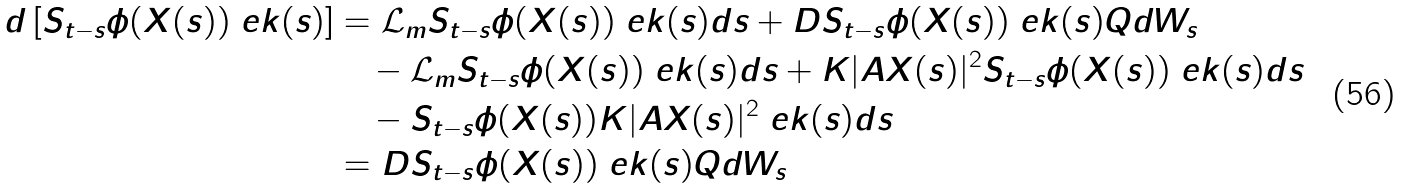<formula> <loc_0><loc_0><loc_500><loc_500>d \left [ S _ { t - s } \phi ( X ( s ) ) \ e k ( s ) \right ] & = \mathcal { L } _ { m } S _ { t - s } \phi ( X ( s ) ) \ e k ( s ) d s + D S _ { t - s } \phi ( X ( s ) ) \ e k ( s ) Q d W _ { s } \\ & \quad - \mathcal { L } _ { m } S _ { t - s } \phi ( X ( s ) ) \ e k ( s ) d s + K | A X ( s ) | ^ { 2 } S _ { t - s } \phi ( X ( s ) ) \ e k ( s ) d s \\ & \quad - S _ { t - s } \phi ( X ( s ) ) K | A X ( s ) | ^ { 2 } \ e k ( s ) d s \\ & = D S _ { t - s } \phi ( X ( s ) ) \ e k ( s ) Q d W _ { s }</formula> 